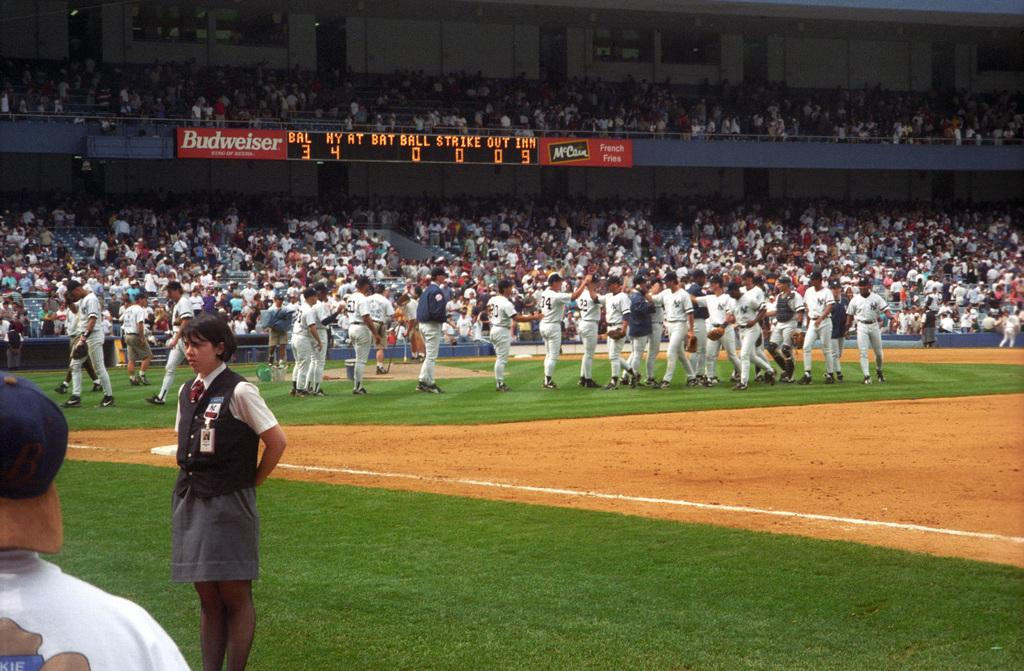<image>
Present a compact description of the photo's key features. Ballpark scoreboard that is above the fans seats that has Budweiser in white on it. 